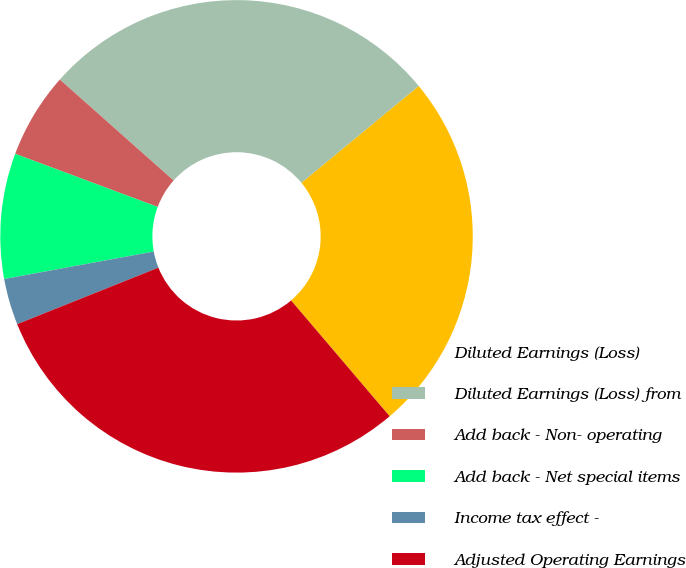Convert chart to OTSL. <chart><loc_0><loc_0><loc_500><loc_500><pie_chart><fcel>Diluted Earnings (Loss)<fcel>Diluted Earnings (Loss) from<fcel>Add back - Non- operating<fcel>Add back - Net special items<fcel>Income tax effect -<fcel>Adjusted Operating Earnings<nl><fcel>24.76%<fcel>27.46%<fcel>5.87%<fcel>8.57%<fcel>3.17%<fcel>30.16%<nl></chart> 